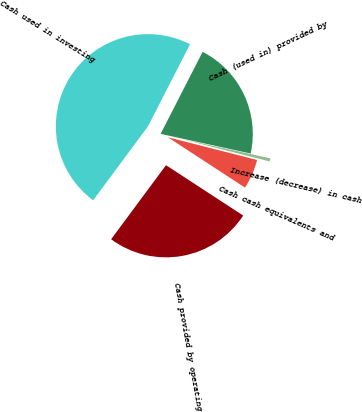Convert chart. <chart><loc_0><loc_0><loc_500><loc_500><pie_chart><fcel>Cash provided by operating<fcel>Cash used in investing<fcel>Cash (used in) provided by<fcel>Increase (decrease) in cash<fcel>Cash cash equivalents and<nl><fcel>25.95%<fcel>47.39%<fcel>20.89%<fcel>0.55%<fcel>5.23%<nl></chart> 